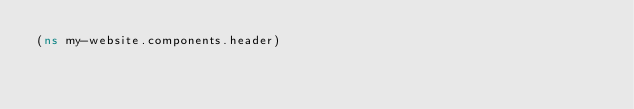Convert code to text. <code><loc_0><loc_0><loc_500><loc_500><_Clojure_>(ns my-website.components.header)
</code> 